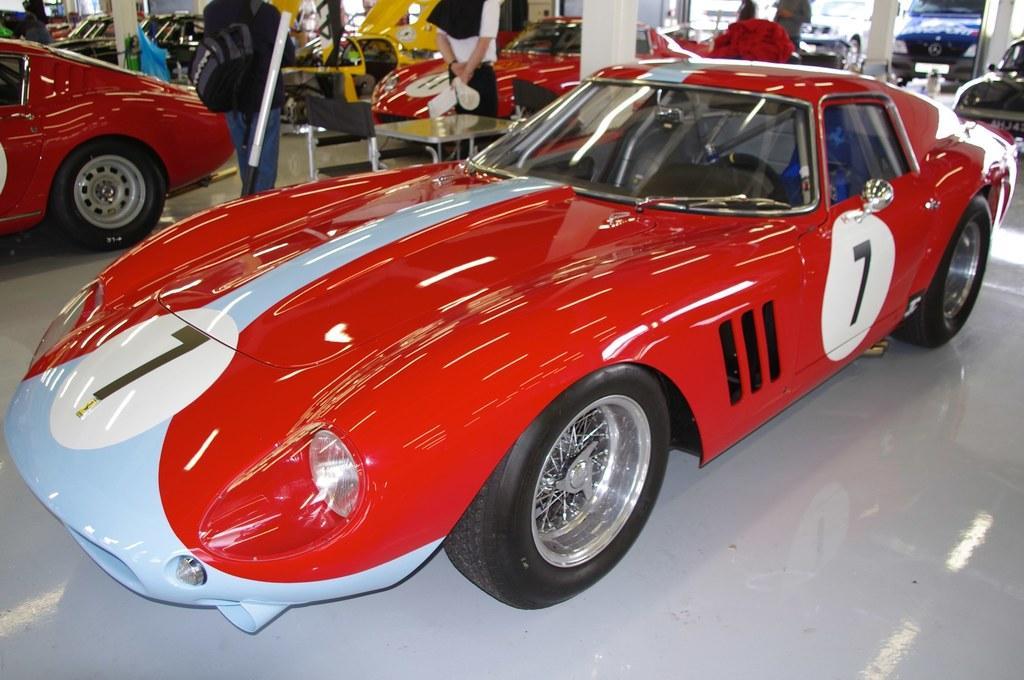Describe this image in one or two sentences. In this image there are many vehicles. Also there are few people standing. And there is a table. And there are pillars. 